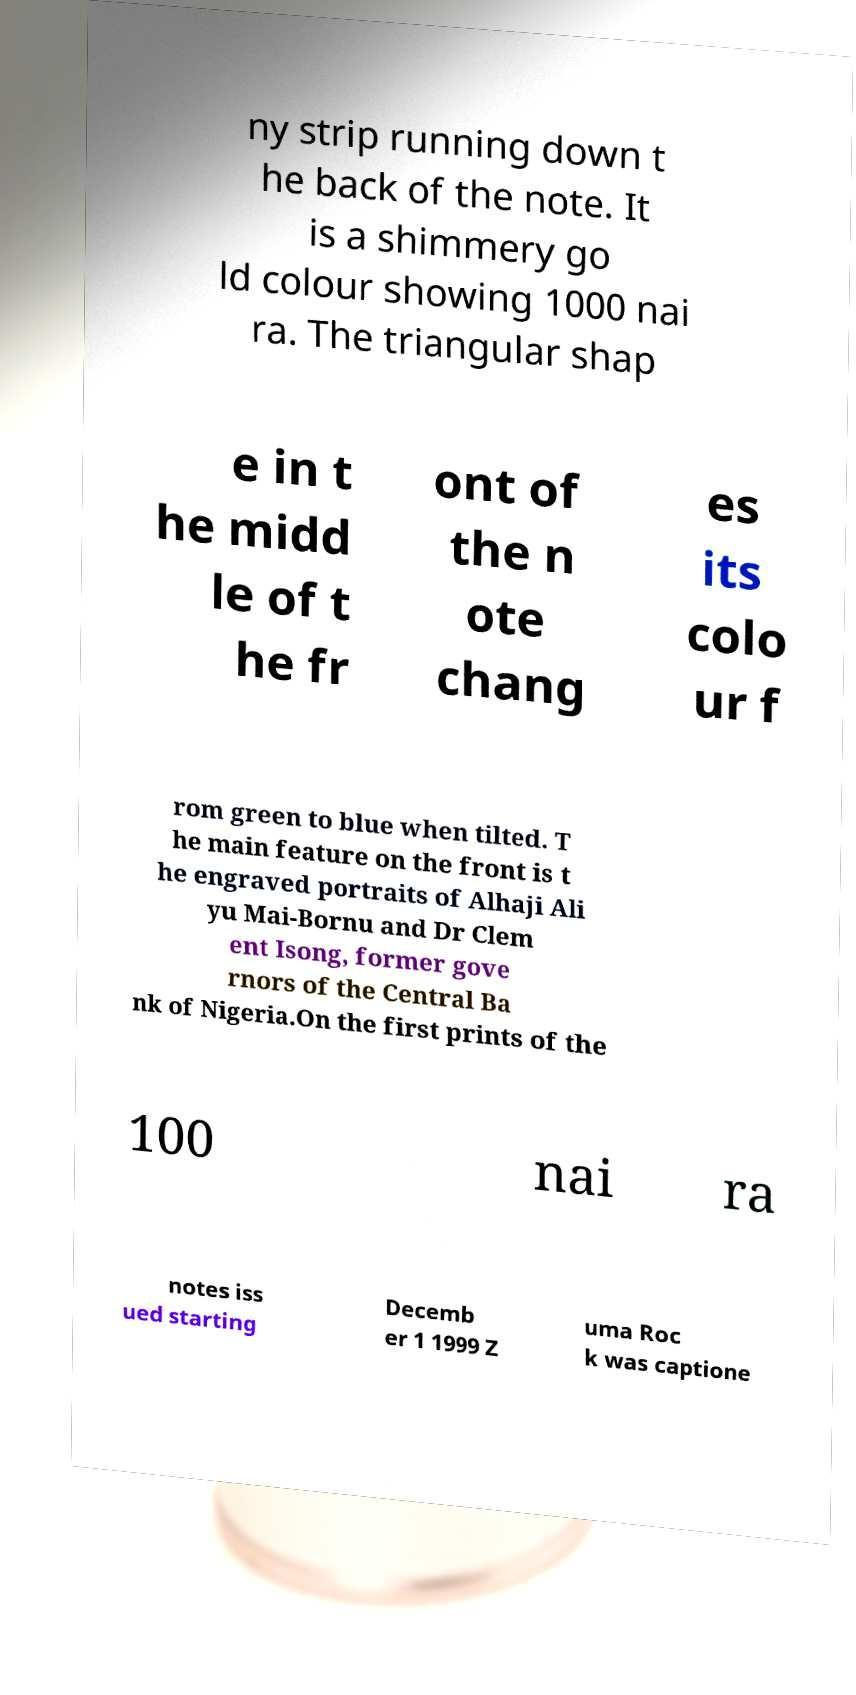Please identify and transcribe the text found in this image. ny strip running down t he back of the note. It is a shimmery go ld colour showing 1000 nai ra. The triangular shap e in t he midd le of t he fr ont of the n ote chang es its colo ur f rom green to blue when tilted. T he main feature on the front is t he engraved portraits of Alhaji Ali yu Mai-Bornu and Dr Clem ent Isong, former gove rnors of the Central Ba nk of Nigeria.On the first prints of the 100 nai ra notes iss ued starting Decemb er 1 1999 Z uma Roc k was captione 